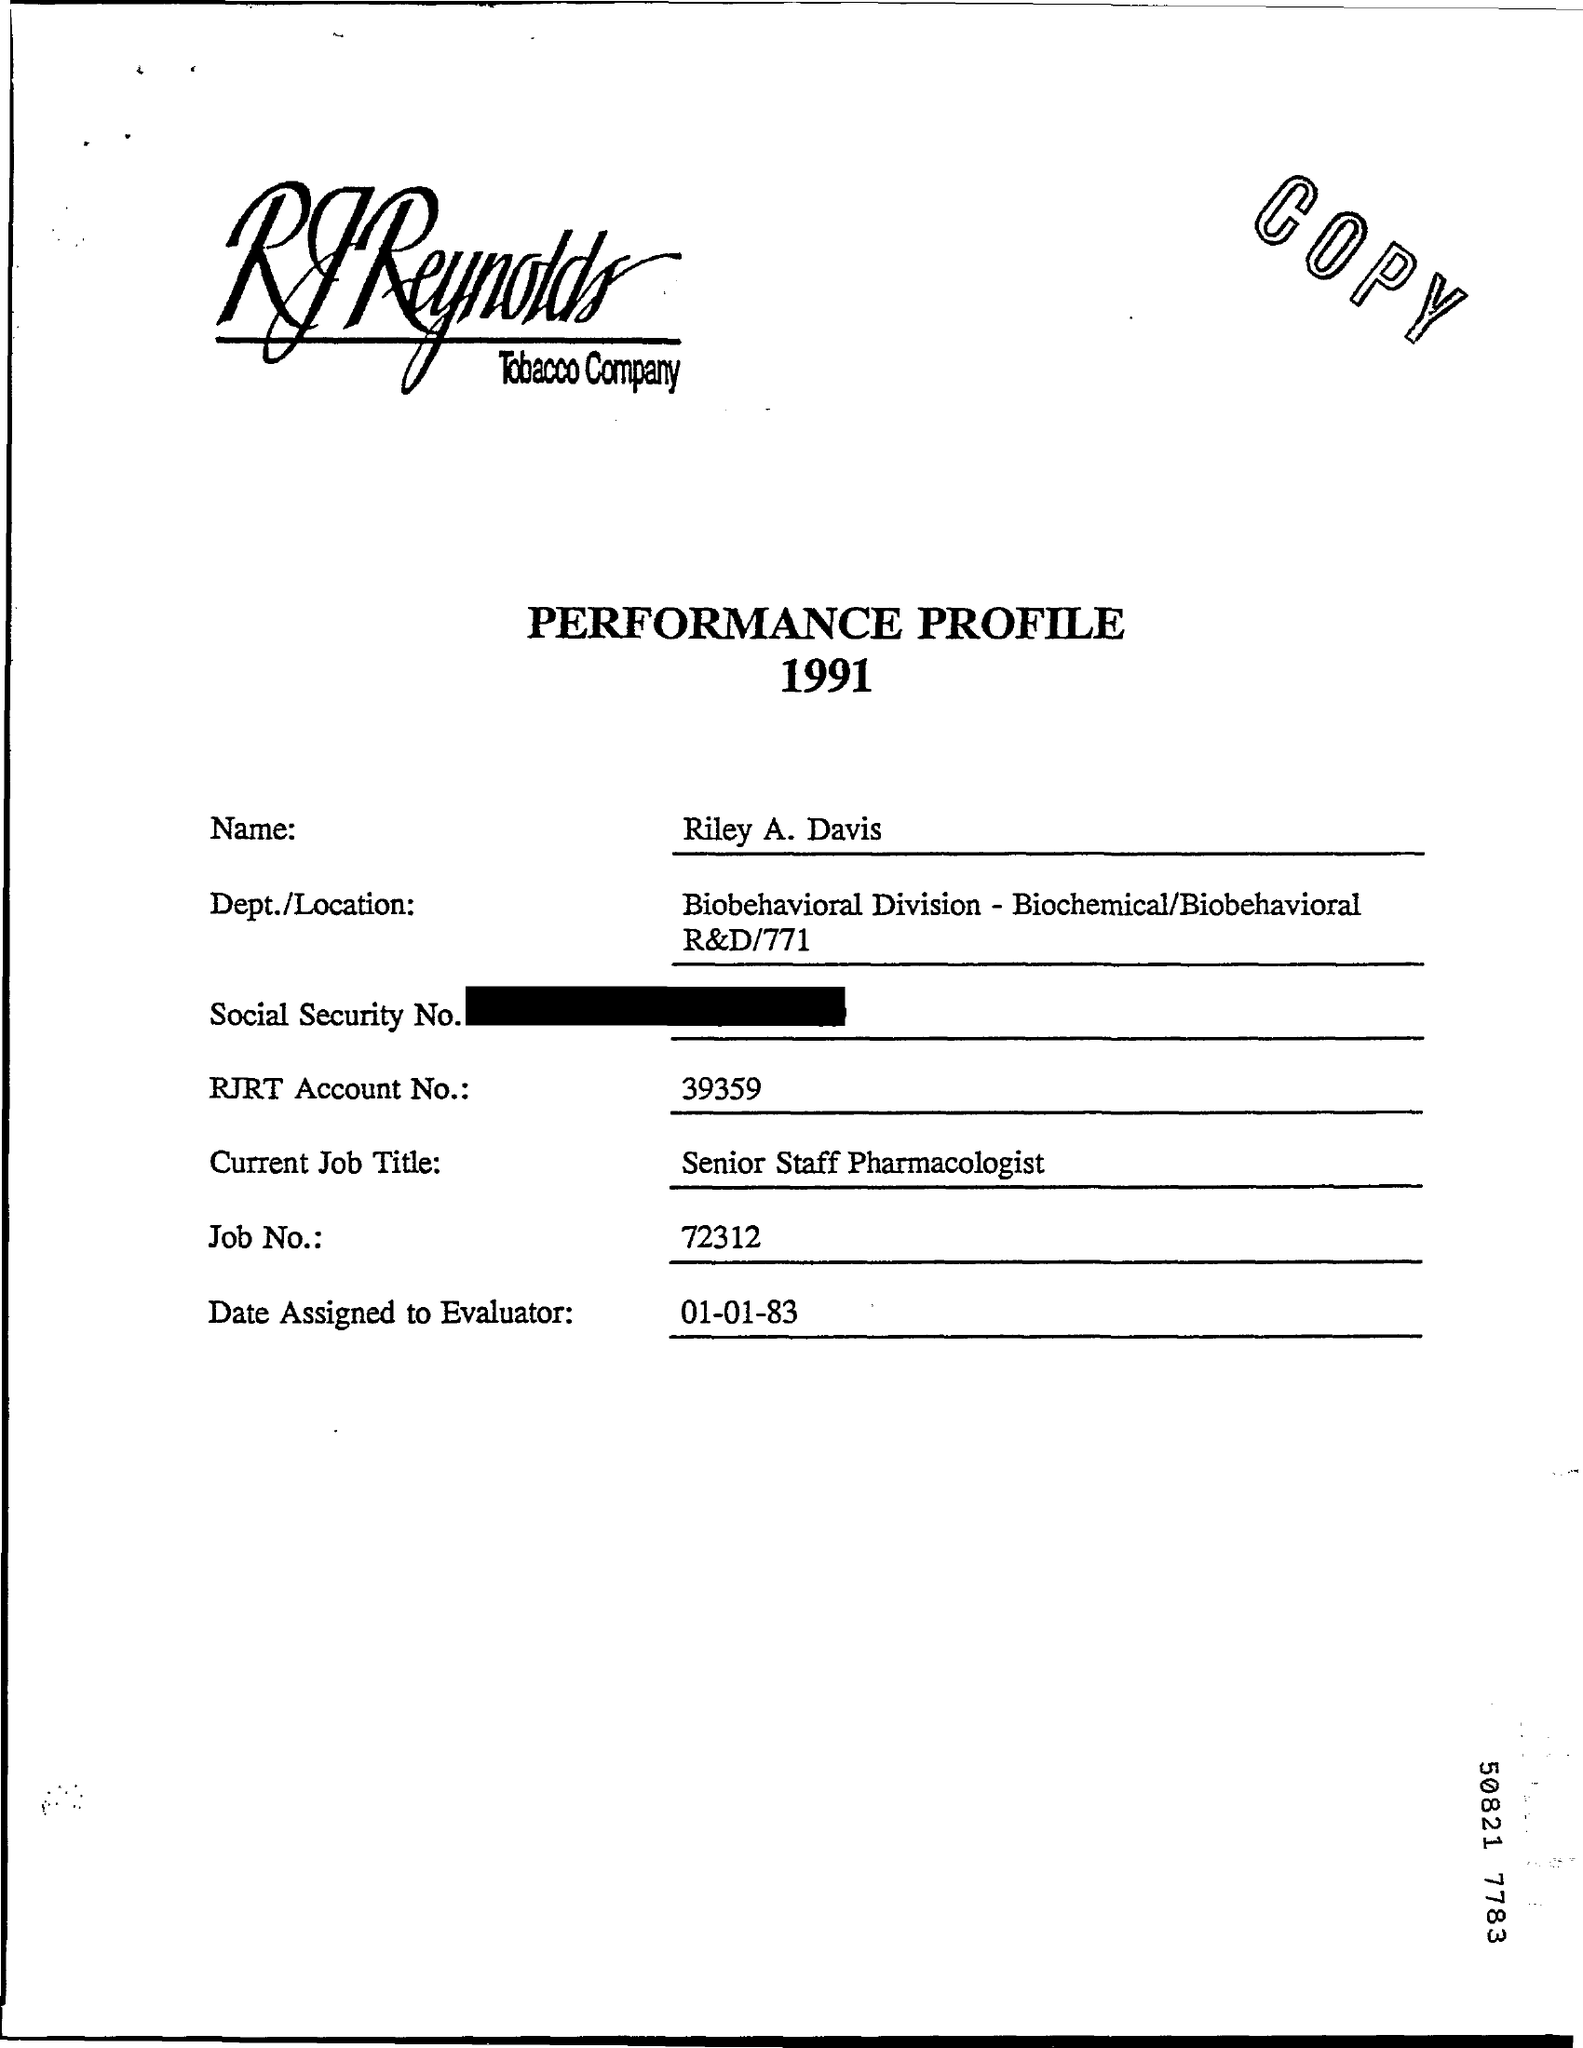What is the Title of the document?
Offer a terse response. Performance profile 1991. What is the Name?
Ensure brevity in your answer.  Riley a. davis. What is the RJRT Account No.?
Your response must be concise. 39359. What is the Current Job Title?
Provide a succinct answer. Senior Staff Pharmacologist. What is the Job No.?
Provide a succinct answer. 72312. What is the Date Assigned to Evaluator?
Your response must be concise. 01-01-83. 